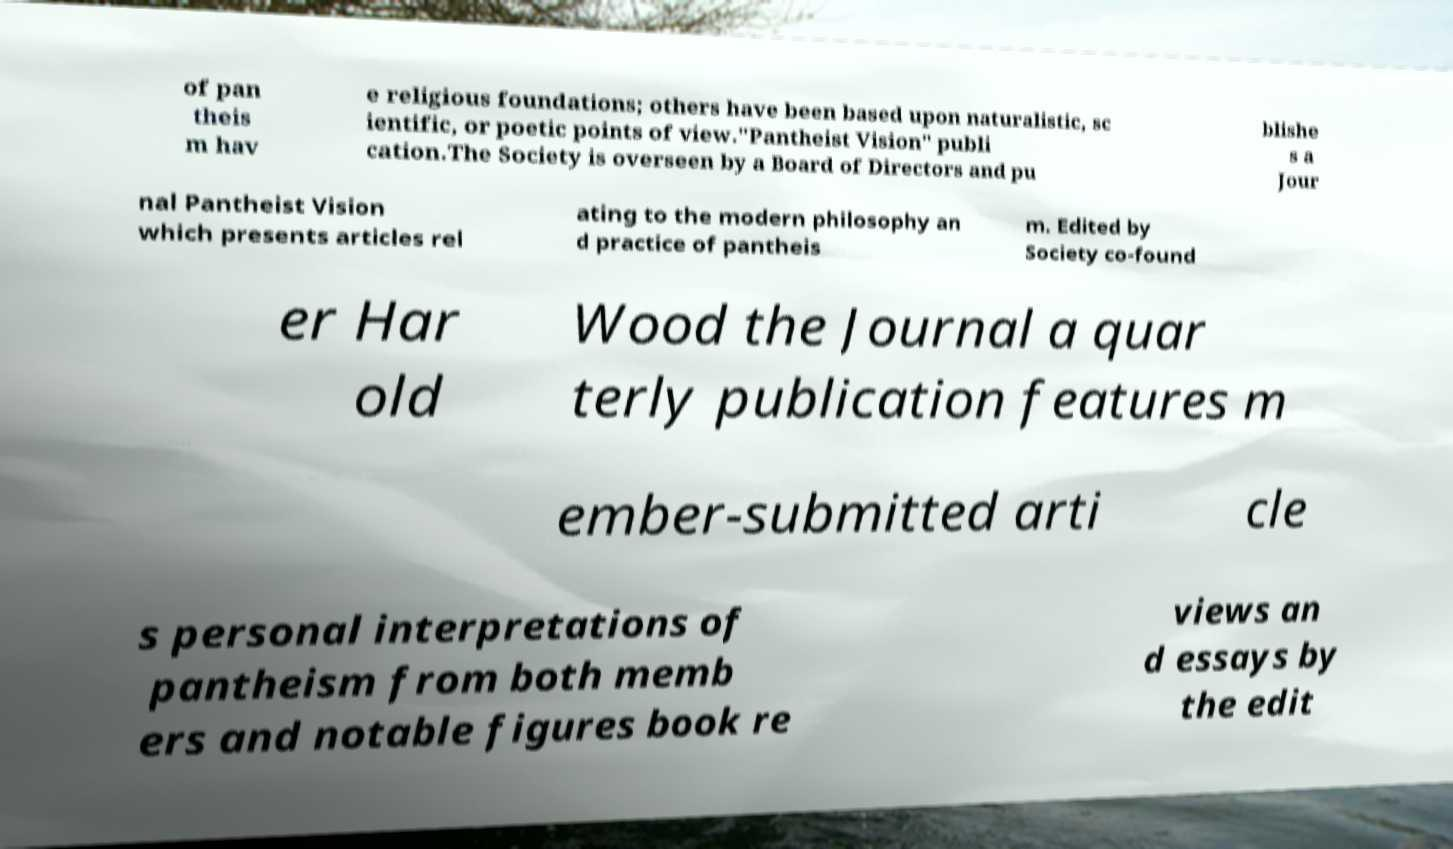Please read and relay the text visible in this image. What does it say? of pan theis m hav e religious foundations; others have been based upon naturalistic, sc ientific, or poetic points of view."Pantheist Vision" publi cation.The Society is overseen by a Board of Directors and pu blishe s a Jour nal Pantheist Vision which presents articles rel ating to the modern philosophy an d practice of pantheis m. Edited by Society co-found er Har old Wood the Journal a quar terly publication features m ember-submitted arti cle s personal interpretations of pantheism from both memb ers and notable figures book re views an d essays by the edit 